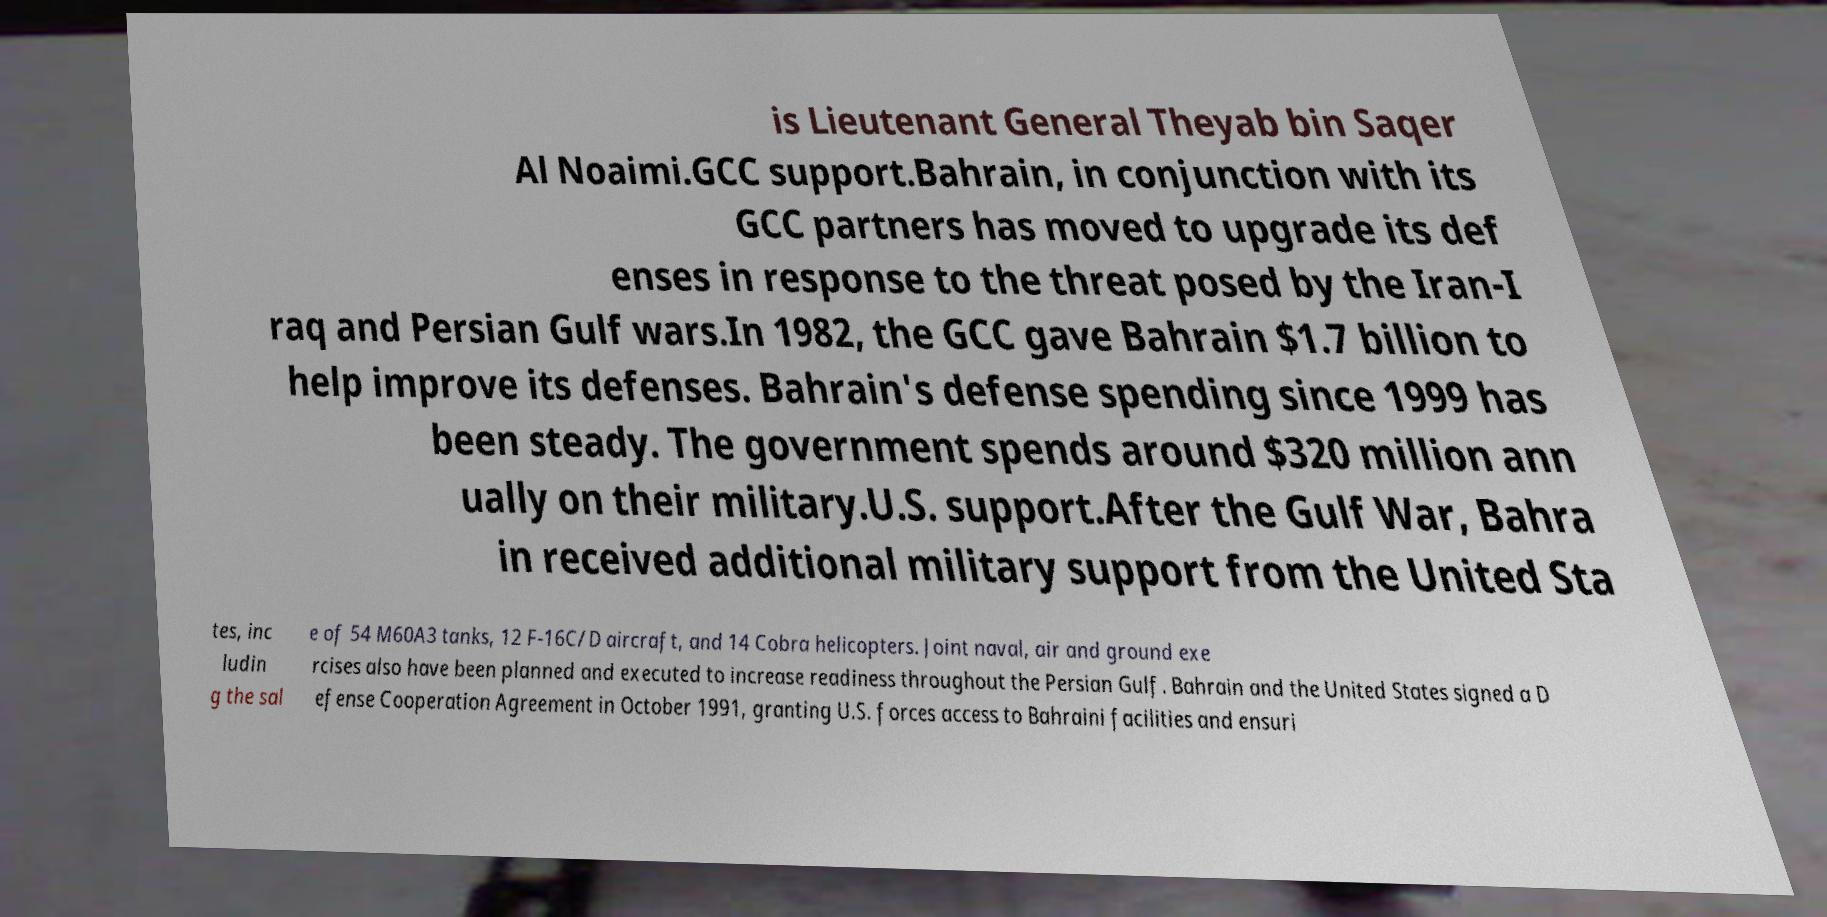What messages or text are displayed in this image? I need them in a readable, typed format. is Lieutenant General Theyab bin Saqer Al Noaimi.GCC support.Bahrain, in conjunction with its GCC partners has moved to upgrade its def enses in response to the threat posed by the Iran-I raq and Persian Gulf wars.In 1982, the GCC gave Bahrain $1.7 billion to help improve its defenses. Bahrain's defense spending since 1999 has been steady. The government spends around $320 million ann ually on their military.U.S. support.After the Gulf War, Bahra in received additional military support from the United Sta tes, inc ludin g the sal e of 54 M60A3 tanks, 12 F-16C/D aircraft, and 14 Cobra helicopters. Joint naval, air and ground exe rcises also have been planned and executed to increase readiness throughout the Persian Gulf. Bahrain and the United States signed a D efense Cooperation Agreement in October 1991, granting U.S. forces access to Bahraini facilities and ensuri 